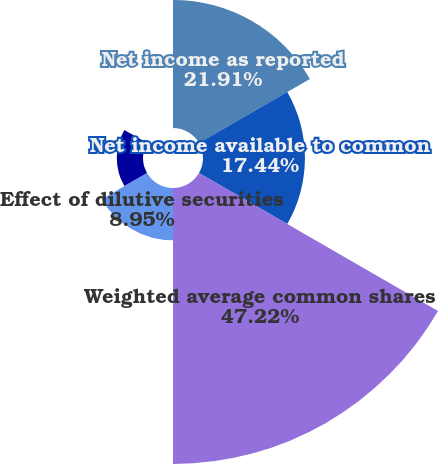Convert chart to OTSL. <chart><loc_0><loc_0><loc_500><loc_500><pie_chart><fcel>Net income as reported<fcel>Net income available to common<fcel>Weighted average common shares<fcel>Effect of dilutive securities<fcel>Earnings per share-basic<fcel>Earnings per share-diluted<nl><fcel>21.91%<fcel>17.44%<fcel>47.22%<fcel>8.95%<fcel>4.48%<fcel>0.0%<nl></chart> 